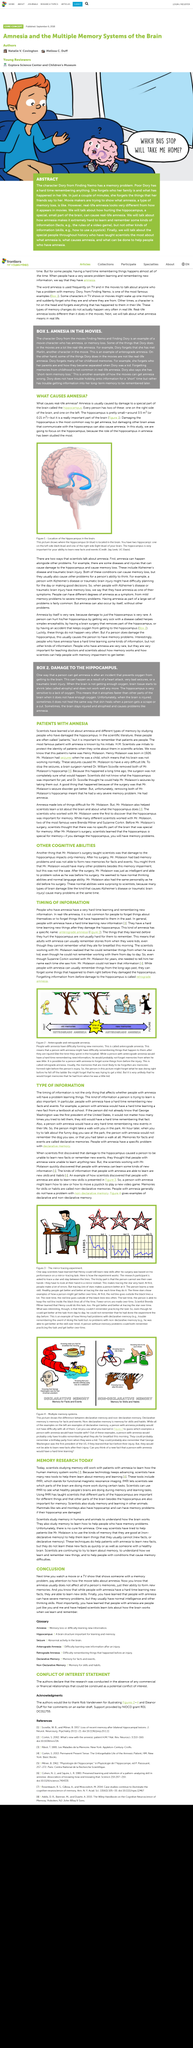Point out several critical features in this image. Amnesia does not affect a person's intelligence. Damage to the hippocampus can result in amnesia, which is characterized by difficulty forming new memories and impaired ability to recall past events. The hippocampus is the brain part that is most important to memory. Amnesia has been instrumental in helping scientists understand how the brain functions, as it provides valuable insights into the nature of memory and the processes that underlie it. People with amnesia have difficulty forming new memories, while those with amnesia struggle to recall past experiences. 